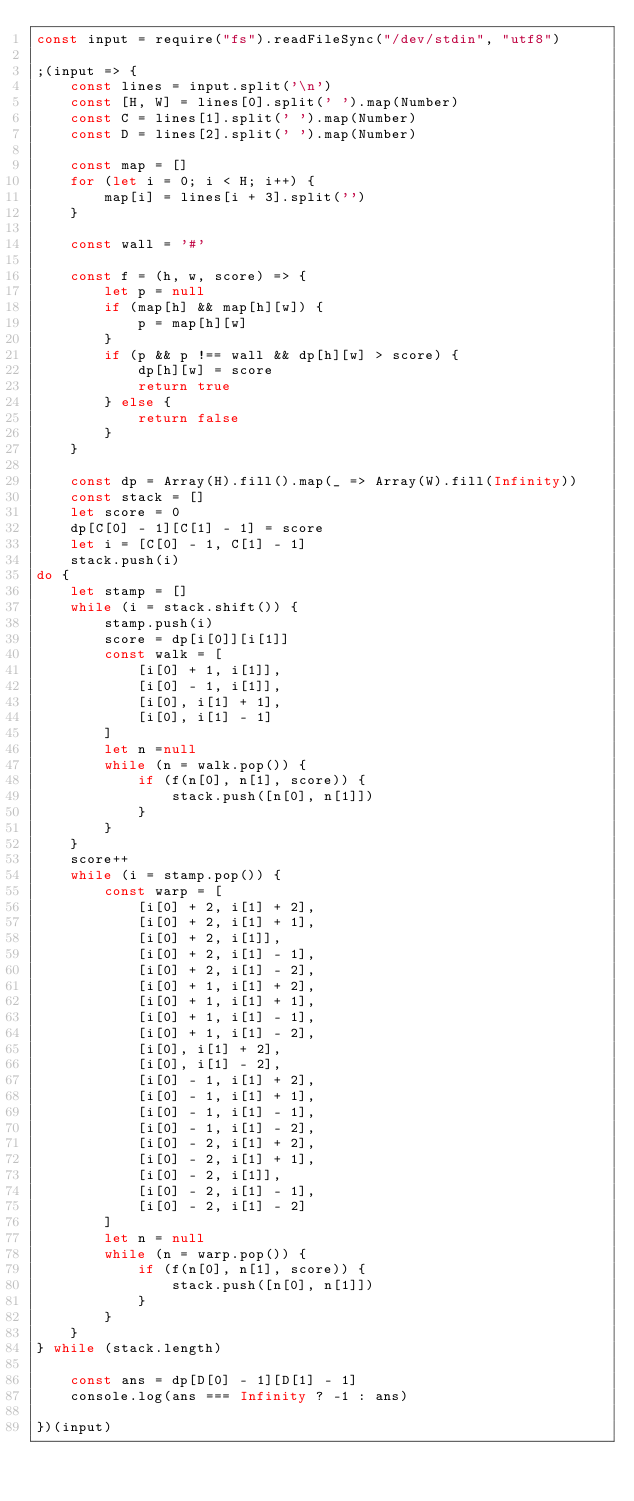<code> <loc_0><loc_0><loc_500><loc_500><_JavaScript_>const input = require("fs").readFileSync("/dev/stdin", "utf8")

;(input => {
    const lines = input.split('\n')
    const [H, W] = lines[0].split(' ').map(Number)
    const C = lines[1].split(' ').map(Number)
    const D = lines[2].split(' ').map(Number)

    const map = []
    for (let i = 0; i < H; i++) {
        map[i] = lines[i + 3].split('')
    }

    const wall = '#'

    const f = (h, w, score) => {
        let p = null
        if (map[h] && map[h][w]) {
            p = map[h][w]
        }
        if (p && p !== wall && dp[h][w] > score) {
            dp[h][w] = score
            return true
        } else {
            return false
        }
    }

    const dp = Array(H).fill().map(_ => Array(W).fill(Infinity))
    const stack = []
    let score = 0
    dp[C[0] - 1][C[1] - 1] = score
    let i = [C[0] - 1, C[1] - 1]
    stack.push(i)
do {
    let stamp = []
    while (i = stack.shift()) {
        stamp.push(i)
        score = dp[i[0]][i[1]]
        const walk = [
            [i[0] + 1, i[1]],
            [i[0] - 1, i[1]],
            [i[0], i[1] + 1],
            [i[0], i[1] - 1]
        ]
        let n =null
        while (n = walk.pop()) {
            if (f(n[0], n[1], score)) {
                stack.push([n[0], n[1]])
            }
        }
    }
    score++
    while (i = stamp.pop()) {
        const warp = [
            [i[0] + 2, i[1] + 2],
            [i[0] + 2, i[1] + 1],
            [i[0] + 2, i[1]],
            [i[0] + 2, i[1] - 1],
            [i[0] + 2, i[1] - 2],
            [i[0] + 1, i[1] + 2],
            [i[0] + 1, i[1] + 1],
            [i[0] + 1, i[1] - 1],
            [i[0] + 1, i[1] - 2],
            [i[0], i[1] + 2],
            [i[0], i[1] - 2],
            [i[0] - 1, i[1] + 2],
            [i[0] - 1, i[1] + 1],
            [i[0] - 1, i[1] - 1],
            [i[0] - 1, i[1] - 2],
            [i[0] - 2, i[1] + 2],
            [i[0] - 2, i[1] + 1],
            [i[0] - 2, i[1]],
            [i[0] - 2, i[1] - 1],
            [i[0] - 2, i[1] - 2]
        ]
        let n = null
        while (n = warp.pop()) {
            if (f(n[0], n[1], score)) {
                stack.push([n[0], n[1]])
            }
        }
    }
} while (stack.length)

    const ans = dp[D[0] - 1][D[1] - 1]
    console.log(ans === Infinity ? -1 : ans)

})(input)
</code> 